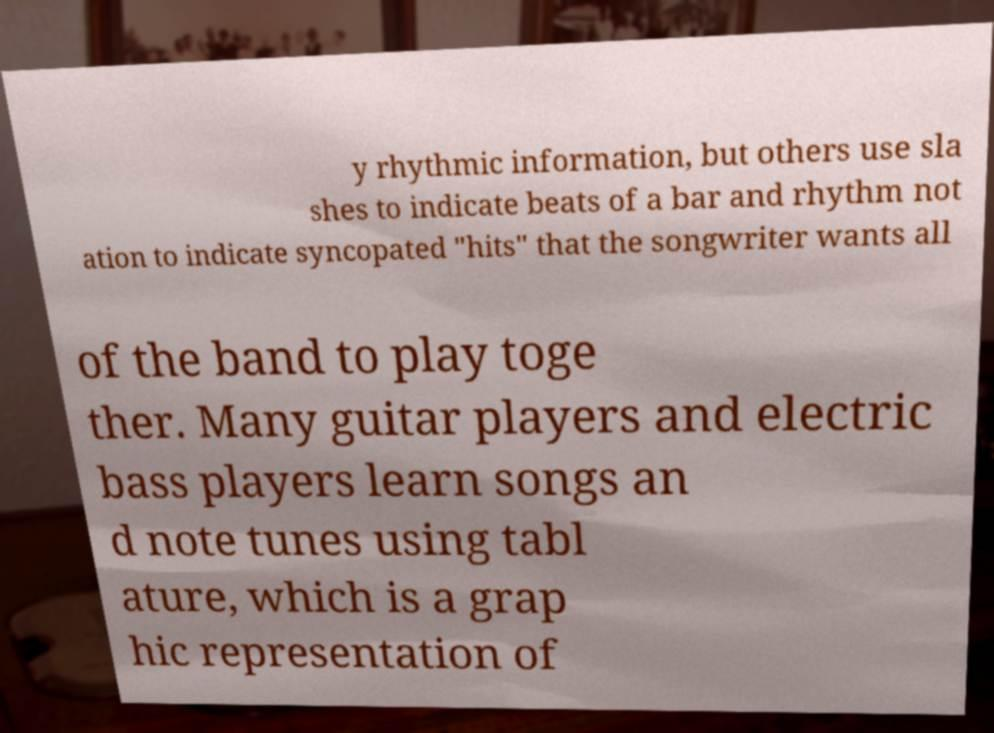I need the written content from this picture converted into text. Can you do that? y rhythmic information, but others use sla shes to indicate beats of a bar and rhythm not ation to indicate syncopated "hits" that the songwriter wants all of the band to play toge ther. Many guitar players and electric bass players learn songs an d note tunes using tabl ature, which is a grap hic representation of 